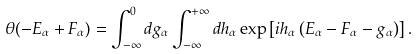<formula> <loc_0><loc_0><loc_500><loc_500>\theta ( - E _ { \alpha } + F _ { \alpha } ) = \int _ { - \infty } ^ { 0 } d g _ { \alpha } \int _ { - \infty } ^ { + \infty } d h _ { \alpha } \exp \left [ i h _ { \alpha } \left ( E _ { \alpha } - F _ { \alpha } - g _ { \alpha } \right ) \right ] .</formula> 